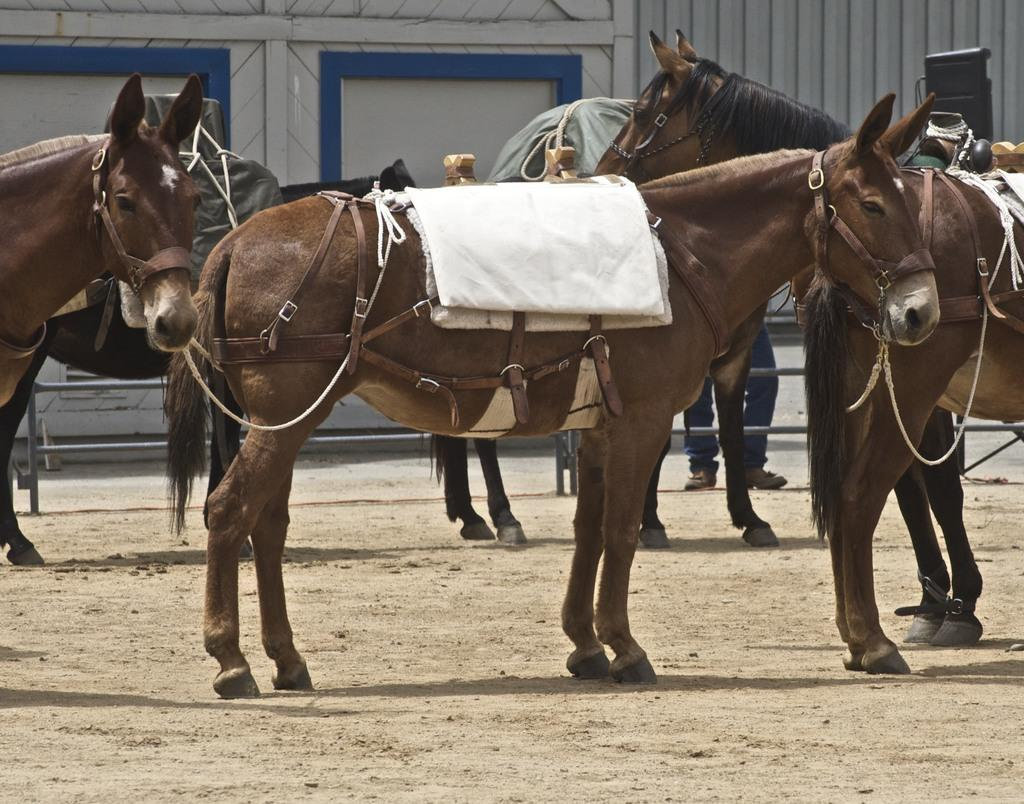What animals are in the center of the image? There are horses standing in the center of the image. What type of terrain is visible in the background? There is sand on the ground in the background. What structures can be seen in the background? There is a door and a wall in the background. What type of mountain can be seen in the background of the image? There is no mountain present in the image; it features horses standing on sandy terrain with a door and a wall in the background. 